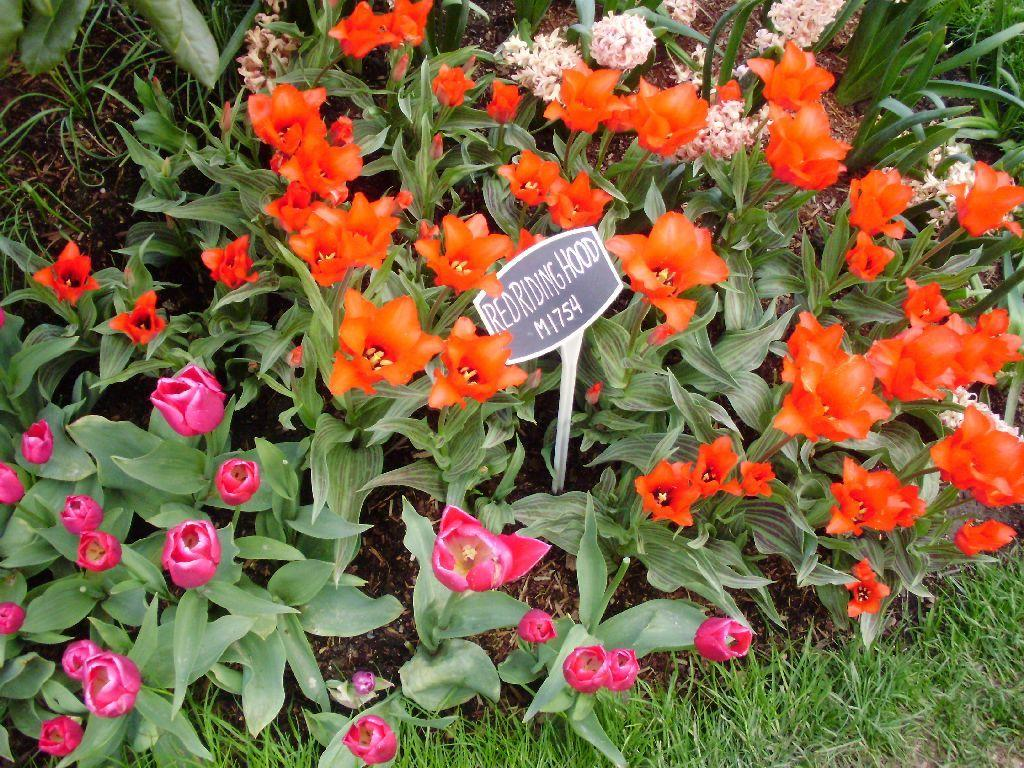What type of vegetation is present in the image? There are plants and flowers in the image. What type of ground cover is visible in the image? There is grass in the image. What is located in the center of the image? There is a board in the center of the image. What is written or depicted on the board? There is text on the board. How many women are holding rats in the image? There are no women or rats present in the image. 